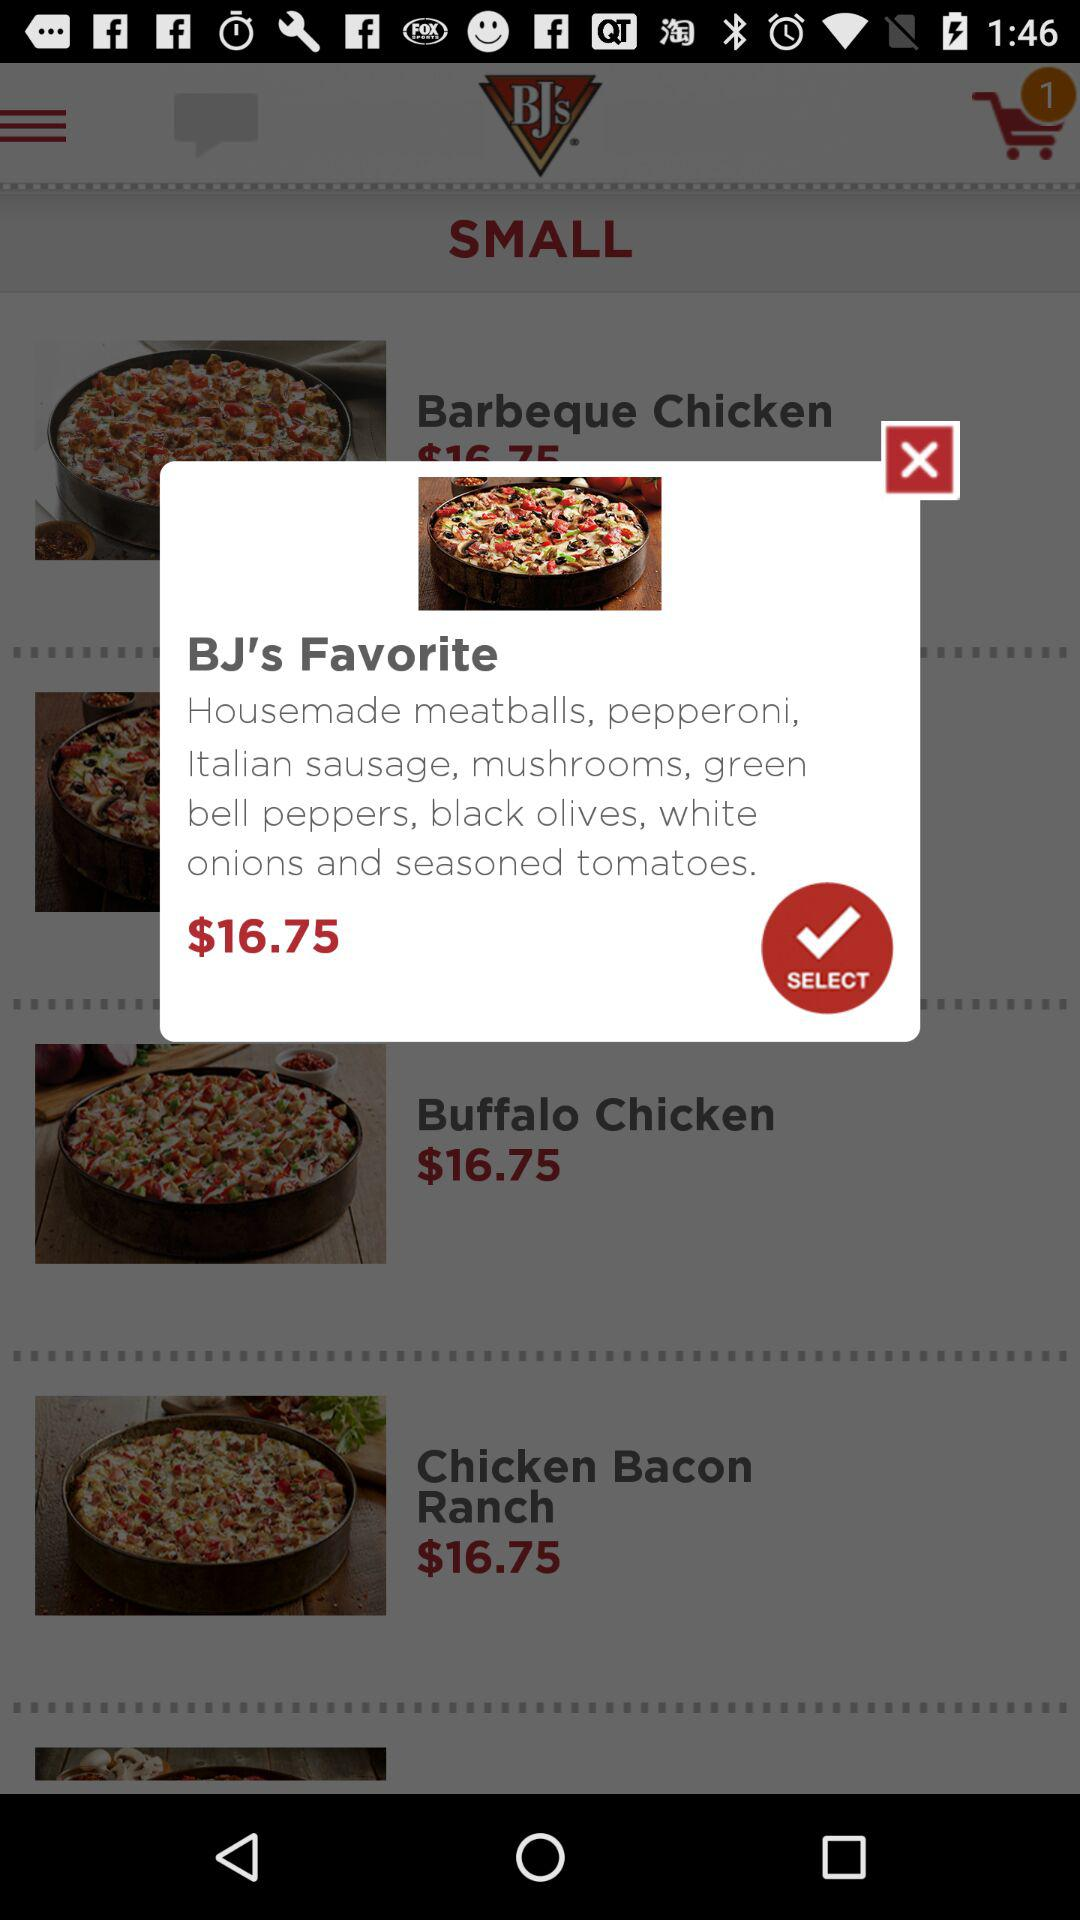What is the price of BJ's Favorite? The price of BJ's Favorites is 16.75 dollars. 